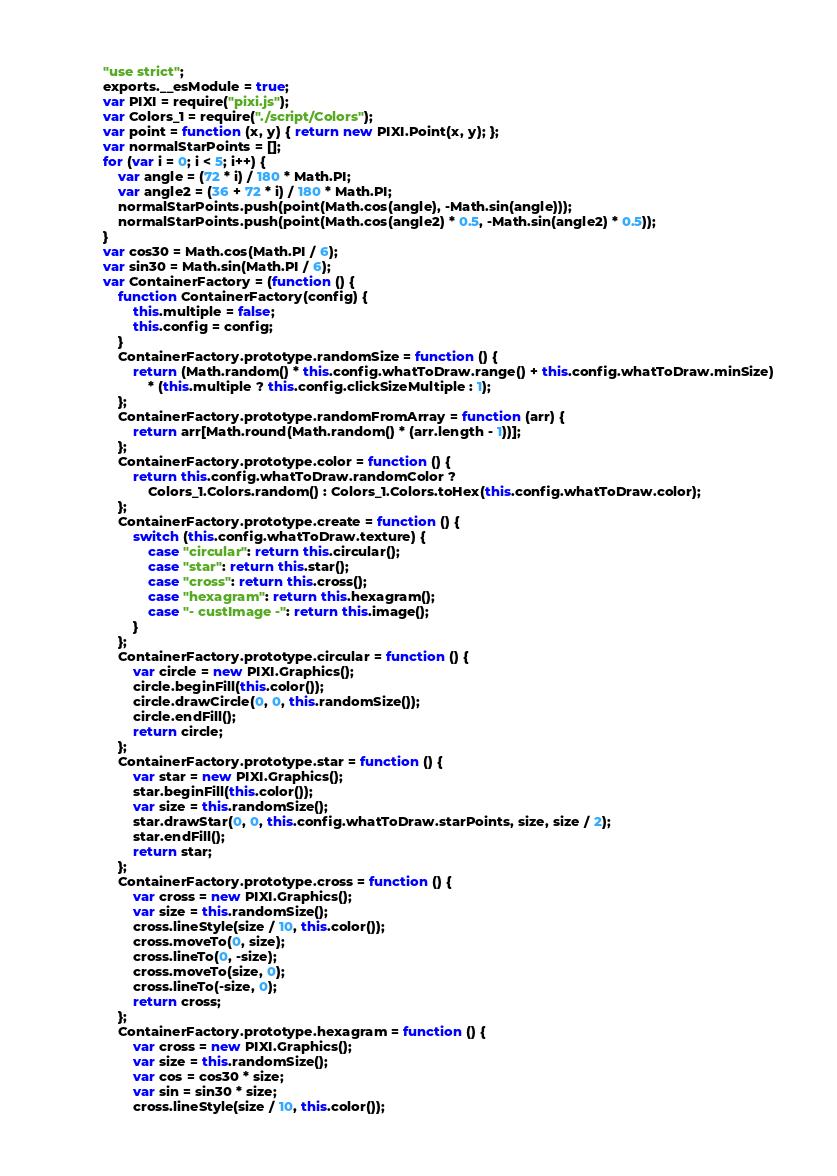Convert code to text. <code><loc_0><loc_0><loc_500><loc_500><_JavaScript_>"use strict";
exports.__esModule = true;
var PIXI = require("pixi.js");
var Colors_1 = require("./script/Colors");
var point = function (x, y) { return new PIXI.Point(x, y); };
var normalStarPoints = [];
for (var i = 0; i < 5; i++) {
    var angle = (72 * i) / 180 * Math.PI;
    var angle2 = (36 + 72 * i) / 180 * Math.PI;
    normalStarPoints.push(point(Math.cos(angle), -Math.sin(angle)));
    normalStarPoints.push(point(Math.cos(angle2) * 0.5, -Math.sin(angle2) * 0.5));
}
var cos30 = Math.cos(Math.PI / 6);
var sin30 = Math.sin(Math.PI / 6);
var ContainerFactory = (function () {
    function ContainerFactory(config) {
        this.multiple = false;
        this.config = config;
    }
    ContainerFactory.prototype.randomSize = function () {
        return (Math.random() * this.config.whatToDraw.range() + this.config.whatToDraw.minSize)
            * (this.multiple ? this.config.clickSizeMultiple : 1);
    };
    ContainerFactory.prototype.randomFromArray = function (arr) {
        return arr[Math.round(Math.random() * (arr.length - 1))];
    };
    ContainerFactory.prototype.color = function () {
        return this.config.whatToDraw.randomColor ?
            Colors_1.Colors.random() : Colors_1.Colors.toHex(this.config.whatToDraw.color);
    };
    ContainerFactory.prototype.create = function () {
        switch (this.config.whatToDraw.texture) {
            case "circular": return this.circular();
            case "star": return this.star();
            case "cross": return this.cross();
            case "hexagram": return this.hexagram();
            case "- custImage -": return this.image();
        }
    };
    ContainerFactory.prototype.circular = function () {
        var circle = new PIXI.Graphics();
        circle.beginFill(this.color());
        circle.drawCircle(0, 0, this.randomSize());
        circle.endFill();
        return circle;
    };
    ContainerFactory.prototype.star = function () {
        var star = new PIXI.Graphics();
        star.beginFill(this.color());
        var size = this.randomSize();
        star.drawStar(0, 0, this.config.whatToDraw.starPoints, size, size / 2);
        star.endFill();
        return star;
    };
    ContainerFactory.prototype.cross = function () {
        var cross = new PIXI.Graphics();
        var size = this.randomSize();
        cross.lineStyle(size / 10, this.color());
        cross.moveTo(0, size);
        cross.lineTo(0, -size);
        cross.moveTo(size, 0);
        cross.lineTo(-size, 0);
        return cross;
    };
    ContainerFactory.prototype.hexagram = function () {
        var cross = new PIXI.Graphics();
        var size = this.randomSize();
        var cos = cos30 * size;
        var sin = sin30 * size;
        cross.lineStyle(size / 10, this.color());</code> 